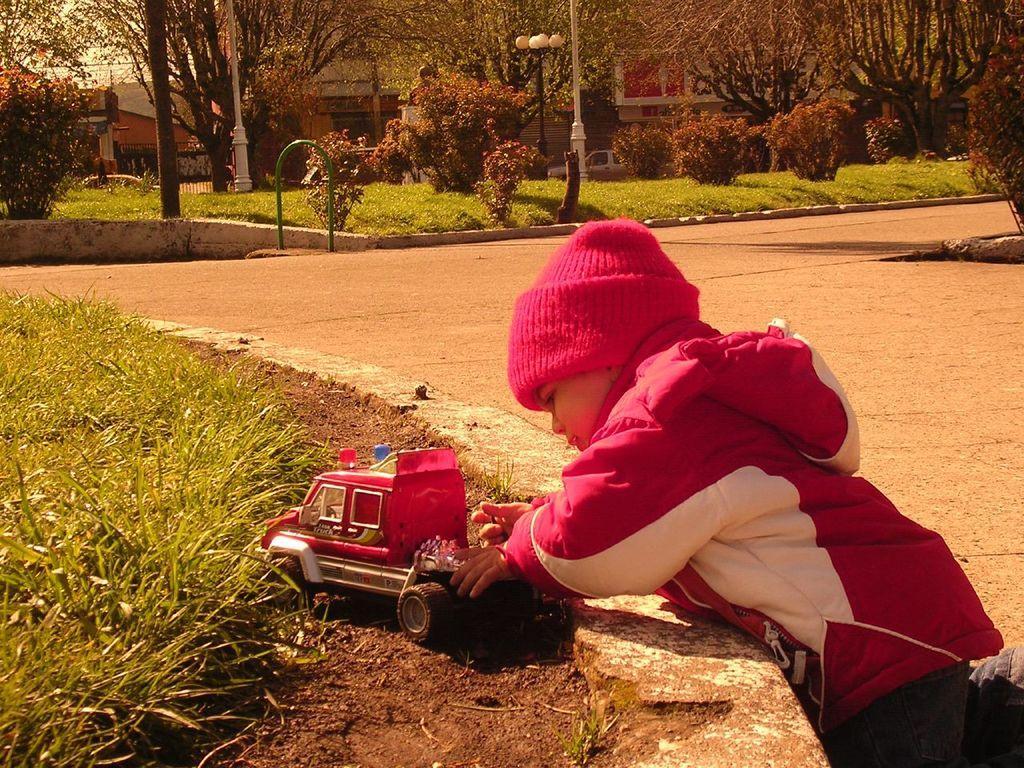In one or two sentences, can you explain what this image depicts? In this image I can see the person playing with the toy car and the person is wearing pink color dress and pink color cap. In the background I can see few light poles, plants and trees in green color and the sky is in white color. 